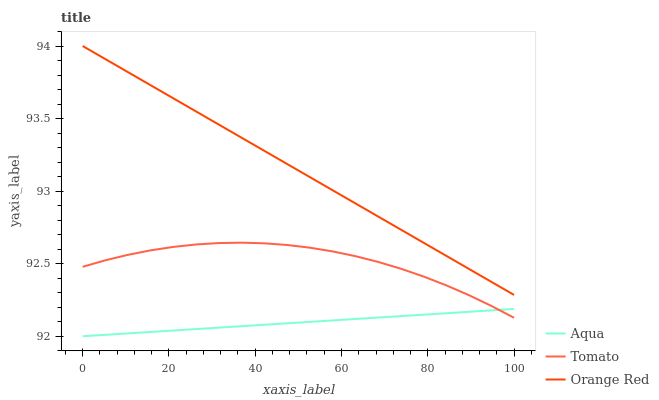Does Aqua have the minimum area under the curve?
Answer yes or no. Yes. Does Orange Red have the maximum area under the curve?
Answer yes or no. Yes. Does Orange Red have the minimum area under the curve?
Answer yes or no. No. Does Aqua have the maximum area under the curve?
Answer yes or no. No. Is Orange Red the smoothest?
Answer yes or no. Yes. Is Tomato the roughest?
Answer yes or no. Yes. Is Aqua the smoothest?
Answer yes or no. No. Is Aqua the roughest?
Answer yes or no. No. Does Orange Red have the lowest value?
Answer yes or no. No. Does Orange Red have the highest value?
Answer yes or no. Yes. Does Aqua have the highest value?
Answer yes or no. No. Is Tomato less than Orange Red?
Answer yes or no. Yes. Is Orange Red greater than Aqua?
Answer yes or no. Yes. Does Aqua intersect Tomato?
Answer yes or no. Yes. Is Aqua less than Tomato?
Answer yes or no. No. Is Aqua greater than Tomato?
Answer yes or no. No. Does Tomato intersect Orange Red?
Answer yes or no. No. 